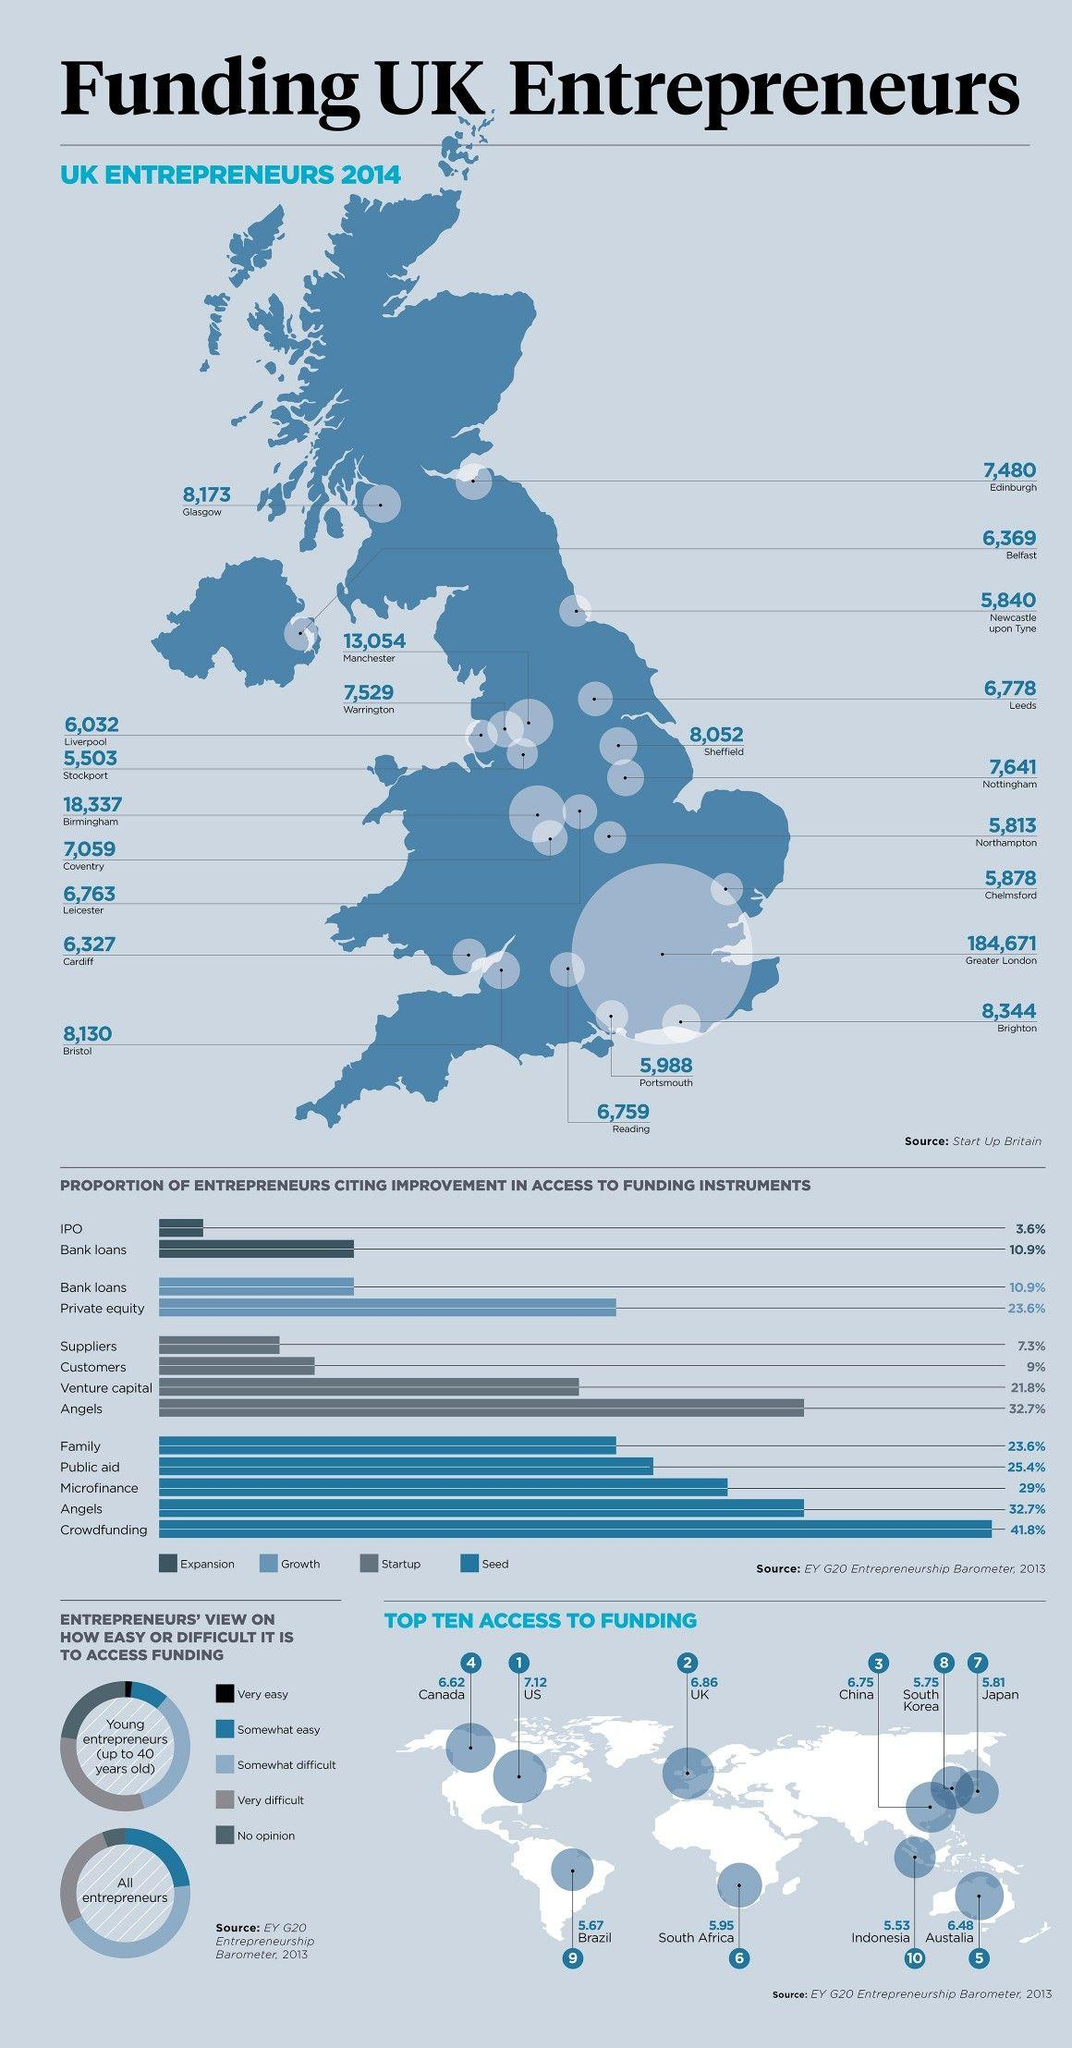Draw attention to some important aspects in this diagram. The United States is in the top position in the list of the top ten access to funding. The location with the highest number of entrepreneurs is Greater London. In 2014, Manchester was the city that saw the third highest number of start-ups. The majority of entrepreneurs consider access to funding to be somewhat difficult. In 2014, a total of 6,327 start-ups were registered in the city of Cardiff. 